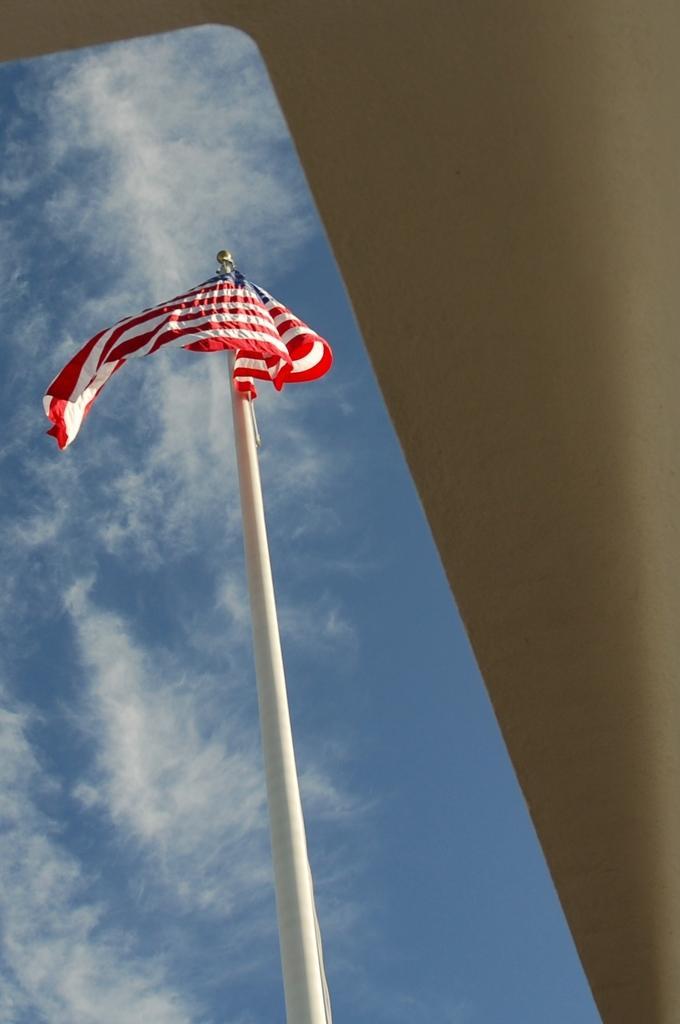How would you summarize this image in a sentence or two? In this image, we can see a white color pole, on that pole there is a flag, in the background we can see blue color sky. 